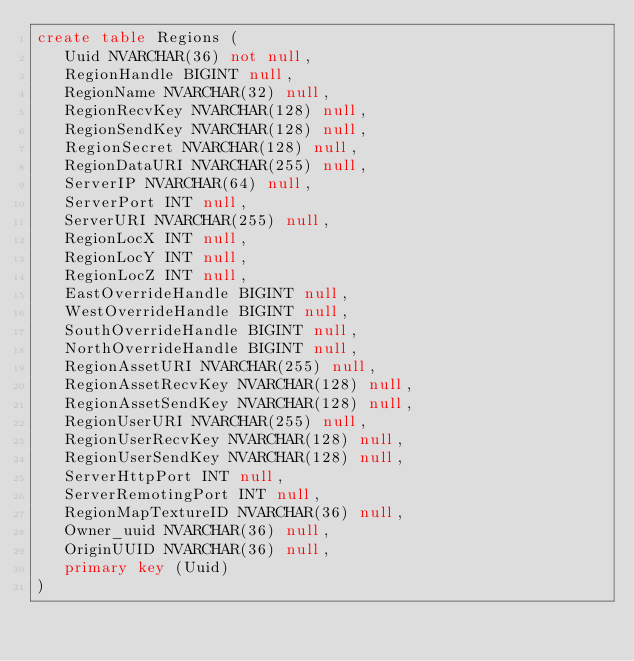Convert code to text. <code><loc_0><loc_0><loc_500><loc_500><_SQL_>create table Regions (
   Uuid NVARCHAR(36) not null,
   RegionHandle BIGINT null,
   RegionName NVARCHAR(32) null,
   RegionRecvKey NVARCHAR(128) null,
   RegionSendKey NVARCHAR(128) null,
   RegionSecret NVARCHAR(128) null,
   RegionDataURI NVARCHAR(255) null,
   ServerIP NVARCHAR(64) null,
   ServerPort INT null,
   ServerURI NVARCHAR(255) null,
   RegionLocX INT null,
   RegionLocY INT null,
   RegionLocZ INT null,
   EastOverrideHandle BIGINT null,
   WestOverrideHandle BIGINT null,
   SouthOverrideHandle BIGINT null,
   NorthOverrideHandle BIGINT null,
   RegionAssetURI NVARCHAR(255) null,
   RegionAssetRecvKey NVARCHAR(128) null,
   RegionAssetSendKey NVARCHAR(128) null,
   RegionUserURI NVARCHAR(255) null,
   RegionUserRecvKey NVARCHAR(128) null,
   RegionUserSendKey NVARCHAR(128) null,
   ServerHttpPort INT null,
   ServerRemotingPort INT null,
   RegionMapTextureID NVARCHAR(36) null,
   Owner_uuid NVARCHAR(36) null,
   OriginUUID NVARCHAR(36) null,
   primary key (Uuid)
)</code> 